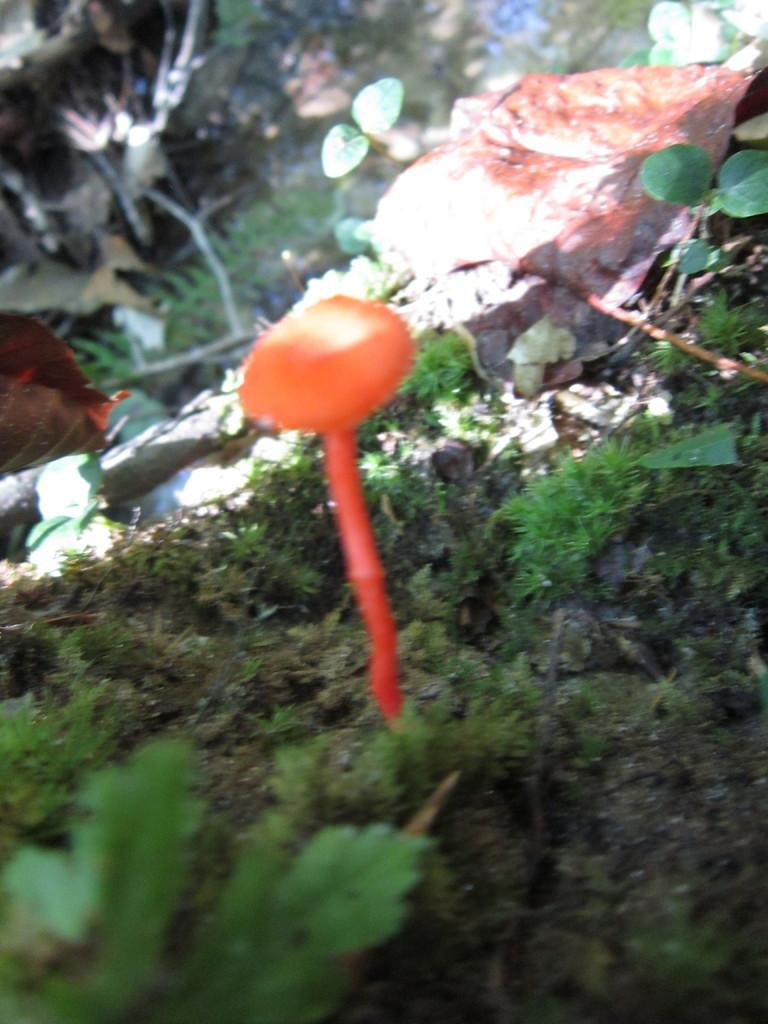What is the main subject in the center of the image? There is a fish in the water in the center of the image. What type of vegetation can be seen in the image? There are leaves visible in the image. What type of ground cover is present at the bottom of the image? There is grass at the bottom of the image. What type of silk is being used to catch the fish in the image? There is no silk or fishing activity present in the image; it features a fish in the water. How many muscles can be seen on the fish in the image? The image does not provide enough detail to determine the number of muscles on the fish. 